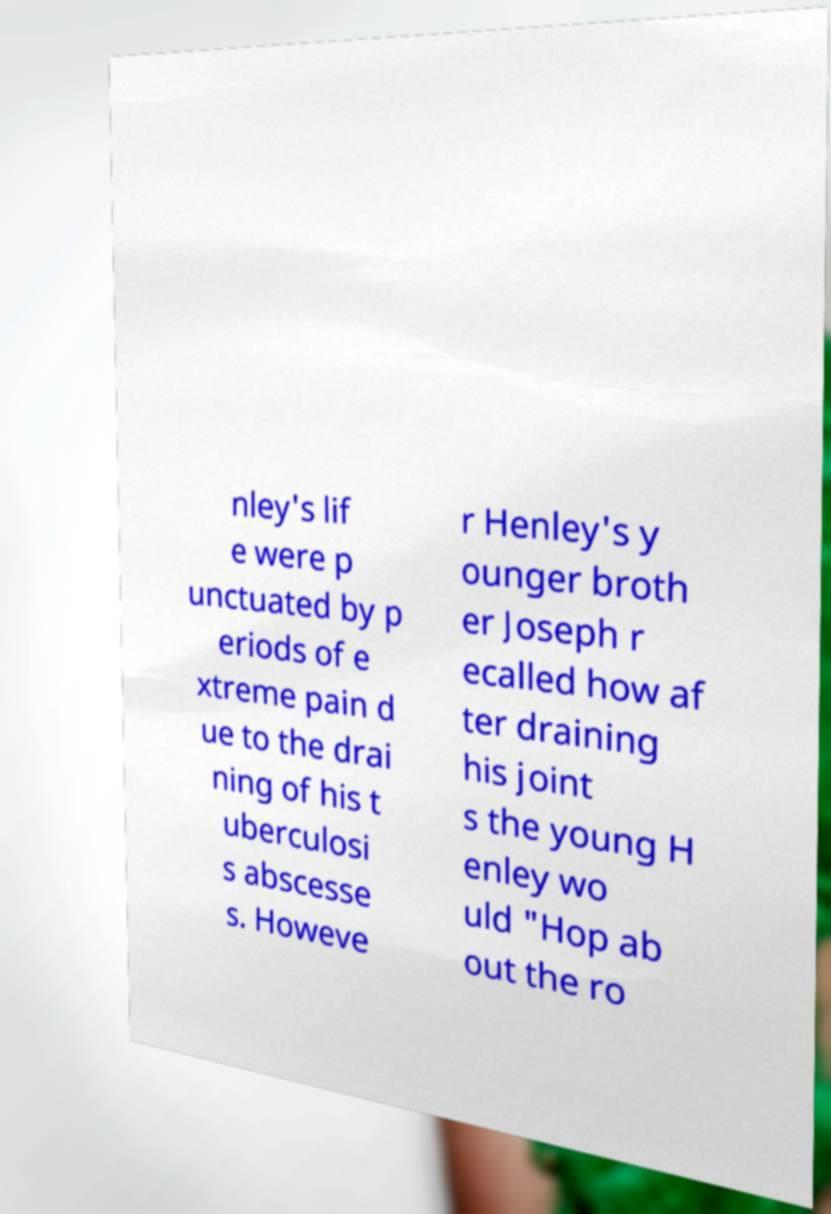Can you accurately transcribe the text from the provided image for me? nley's lif e were p unctuated by p eriods of e xtreme pain d ue to the drai ning of his t uberculosi s abscesse s. Howeve r Henley's y ounger broth er Joseph r ecalled how af ter draining his joint s the young H enley wo uld "Hop ab out the ro 